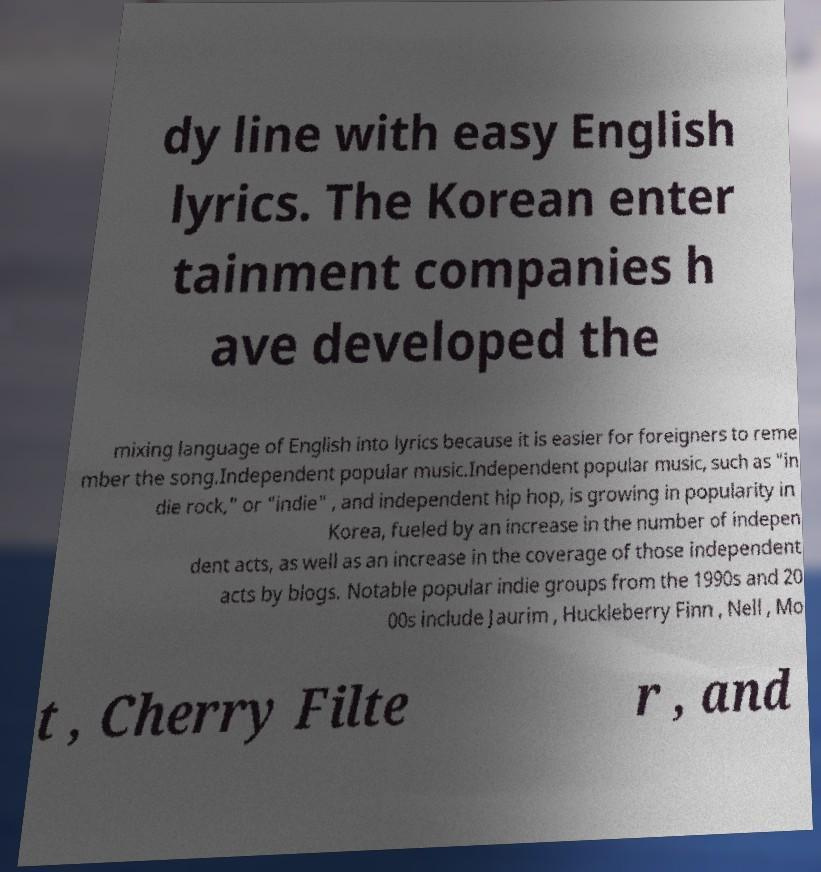Please identify and transcribe the text found in this image. dy line with easy English lyrics. The Korean enter tainment companies h ave developed the mixing language of English into lyrics because it is easier for foreigners to reme mber the song.Independent popular music.Independent popular music, such as "in die rock," or "indie" , and independent hip hop, is growing in popularity in Korea, fueled by an increase in the number of indepen dent acts, as well as an increase in the coverage of those independent acts by blogs. Notable popular indie groups from the 1990s and 20 00s include Jaurim , Huckleberry Finn , Nell , Mo t , Cherry Filte r , and 